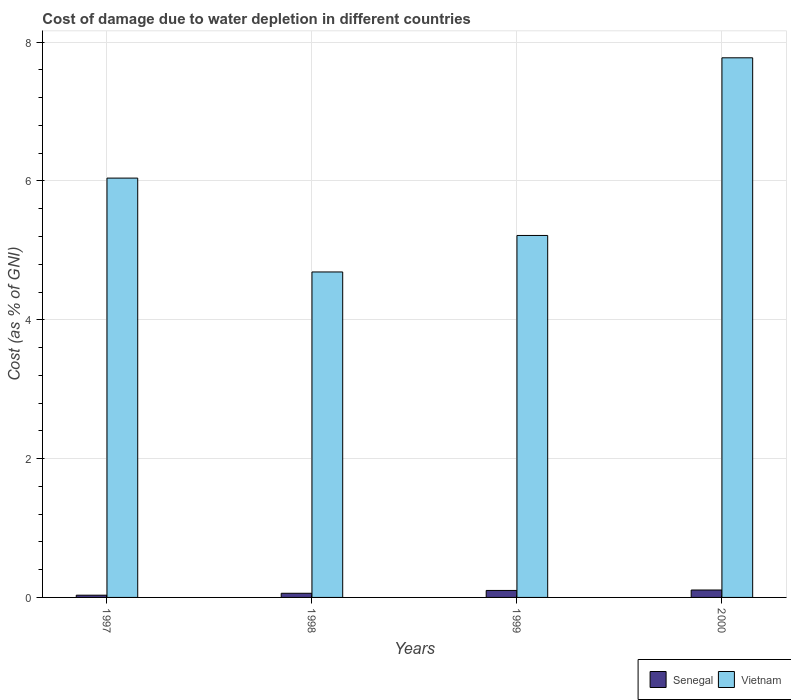How many groups of bars are there?
Provide a short and direct response. 4. Are the number of bars per tick equal to the number of legend labels?
Offer a terse response. Yes. Are the number of bars on each tick of the X-axis equal?
Make the answer very short. Yes. How many bars are there on the 1st tick from the left?
Give a very brief answer. 2. What is the cost of damage caused due to water depletion in Vietnam in 1999?
Your response must be concise. 5.21. Across all years, what is the maximum cost of damage caused due to water depletion in Senegal?
Give a very brief answer. 0.11. Across all years, what is the minimum cost of damage caused due to water depletion in Vietnam?
Give a very brief answer. 4.69. What is the total cost of damage caused due to water depletion in Senegal in the graph?
Make the answer very short. 0.3. What is the difference between the cost of damage caused due to water depletion in Senegal in 1997 and that in 2000?
Offer a terse response. -0.07. What is the difference between the cost of damage caused due to water depletion in Senegal in 1998 and the cost of damage caused due to water depletion in Vietnam in 1999?
Give a very brief answer. -5.15. What is the average cost of damage caused due to water depletion in Senegal per year?
Keep it short and to the point. 0.07. In the year 2000, what is the difference between the cost of damage caused due to water depletion in Senegal and cost of damage caused due to water depletion in Vietnam?
Make the answer very short. -7.67. In how many years, is the cost of damage caused due to water depletion in Vietnam greater than 4 %?
Offer a terse response. 4. What is the ratio of the cost of damage caused due to water depletion in Vietnam in 1998 to that in 1999?
Ensure brevity in your answer.  0.9. Is the cost of damage caused due to water depletion in Senegal in 1999 less than that in 2000?
Give a very brief answer. Yes. What is the difference between the highest and the second highest cost of damage caused due to water depletion in Senegal?
Your answer should be very brief. 0.01. What is the difference between the highest and the lowest cost of damage caused due to water depletion in Senegal?
Provide a succinct answer. 0.07. In how many years, is the cost of damage caused due to water depletion in Vietnam greater than the average cost of damage caused due to water depletion in Vietnam taken over all years?
Your answer should be compact. 2. What does the 1st bar from the left in 1999 represents?
Your response must be concise. Senegal. What does the 2nd bar from the right in 1997 represents?
Your response must be concise. Senegal. Are the values on the major ticks of Y-axis written in scientific E-notation?
Provide a short and direct response. No. Does the graph contain any zero values?
Ensure brevity in your answer.  No. Does the graph contain grids?
Provide a succinct answer. Yes. Where does the legend appear in the graph?
Give a very brief answer. Bottom right. How many legend labels are there?
Make the answer very short. 2. How are the legend labels stacked?
Keep it short and to the point. Horizontal. What is the title of the graph?
Give a very brief answer. Cost of damage due to water depletion in different countries. What is the label or title of the X-axis?
Make the answer very short. Years. What is the label or title of the Y-axis?
Keep it short and to the point. Cost (as % of GNI). What is the Cost (as % of GNI) of Senegal in 1997?
Keep it short and to the point. 0.03. What is the Cost (as % of GNI) in Vietnam in 1997?
Give a very brief answer. 6.04. What is the Cost (as % of GNI) in Senegal in 1998?
Your response must be concise. 0.06. What is the Cost (as % of GNI) in Vietnam in 1998?
Provide a short and direct response. 4.69. What is the Cost (as % of GNI) in Senegal in 1999?
Provide a short and direct response. 0.1. What is the Cost (as % of GNI) in Vietnam in 1999?
Your answer should be compact. 5.21. What is the Cost (as % of GNI) in Senegal in 2000?
Offer a very short reply. 0.11. What is the Cost (as % of GNI) in Vietnam in 2000?
Provide a short and direct response. 7.77. Across all years, what is the maximum Cost (as % of GNI) in Senegal?
Offer a very short reply. 0.11. Across all years, what is the maximum Cost (as % of GNI) of Vietnam?
Provide a short and direct response. 7.77. Across all years, what is the minimum Cost (as % of GNI) in Senegal?
Make the answer very short. 0.03. Across all years, what is the minimum Cost (as % of GNI) in Vietnam?
Provide a succinct answer. 4.69. What is the total Cost (as % of GNI) of Senegal in the graph?
Your answer should be compact. 0.3. What is the total Cost (as % of GNI) in Vietnam in the graph?
Make the answer very short. 23.72. What is the difference between the Cost (as % of GNI) of Senegal in 1997 and that in 1998?
Offer a terse response. -0.03. What is the difference between the Cost (as % of GNI) in Vietnam in 1997 and that in 1998?
Provide a succinct answer. 1.35. What is the difference between the Cost (as % of GNI) of Senegal in 1997 and that in 1999?
Offer a very short reply. -0.07. What is the difference between the Cost (as % of GNI) of Vietnam in 1997 and that in 1999?
Your answer should be very brief. 0.83. What is the difference between the Cost (as % of GNI) of Senegal in 1997 and that in 2000?
Provide a succinct answer. -0.07. What is the difference between the Cost (as % of GNI) of Vietnam in 1997 and that in 2000?
Your response must be concise. -1.73. What is the difference between the Cost (as % of GNI) of Senegal in 1998 and that in 1999?
Your answer should be very brief. -0.04. What is the difference between the Cost (as % of GNI) of Vietnam in 1998 and that in 1999?
Your response must be concise. -0.53. What is the difference between the Cost (as % of GNI) of Senegal in 1998 and that in 2000?
Offer a very short reply. -0.05. What is the difference between the Cost (as % of GNI) in Vietnam in 1998 and that in 2000?
Ensure brevity in your answer.  -3.09. What is the difference between the Cost (as % of GNI) in Senegal in 1999 and that in 2000?
Give a very brief answer. -0.01. What is the difference between the Cost (as % of GNI) of Vietnam in 1999 and that in 2000?
Give a very brief answer. -2.56. What is the difference between the Cost (as % of GNI) of Senegal in 1997 and the Cost (as % of GNI) of Vietnam in 1998?
Your response must be concise. -4.66. What is the difference between the Cost (as % of GNI) in Senegal in 1997 and the Cost (as % of GNI) in Vietnam in 1999?
Ensure brevity in your answer.  -5.18. What is the difference between the Cost (as % of GNI) in Senegal in 1997 and the Cost (as % of GNI) in Vietnam in 2000?
Provide a succinct answer. -7.74. What is the difference between the Cost (as % of GNI) in Senegal in 1998 and the Cost (as % of GNI) in Vietnam in 1999?
Your response must be concise. -5.15. What is the difference between the Cost (as % of GNI) in Senegal in 1998 and the Cost (as % of GNI) in Vietnam in 2000?
Your answer should be compact. -7.71. What is the difference between the Cost (as % of GNI) of Senegal in 1999 and the Cost (as % of GNI) of Vietnam in 2000?
Offer a very short reply. -7.67. What is the average Cost (as % of GNI) of Senegal per year?
Your answer should be compact. 0.07. What is the average Cost (as % of GNI) in Vietnam per year?
Provide a short and direct response. 5.93. In the year 1997, what is the difference between the Cost (as % of GNI) of Senegal and Cost (as % of GNI) of Vietnam?
Offer a very short reply. -6.01. In the year 1998, what is the difference between the Cost (as % of GNI) in Senegal and Cost (as % of GNI) in Vietnam?
Make the answer very short. -4.63. In the year 1999, what is the difference between the Cost (as % of GNI) of Senegal and Cost (as % of GNI) of Vietnam?
Your answer should be very brief. -5.11. In the year 2000, what is the difference between the Cost (as % of GNI) of Senegal and Cost (as % of GNI) of Vietnam?
Ensure brevity in your answer.  -7.67. What is the ratio of the Cost (as % of GNI) of Senegal in 1997 to that in 1998?
Keep it short and to the point. 0.54. What is the ratio of the Cost (as % of GNI) in Vietnam in 1997 to that in 1998?
Give a very brief answer. 1.29. What is the ratio of the Cost (as % of GNI) in Senegal in 1997 to that in 1999?
Provide a short and direct response. 0.32. What is the ratio of the Cost (as % of GNI) in Vietnam in 1997 to that in 1999?
Provide a short and direct response. 1.16. What is the ratio of the Cost (as % of GNI) in Senegal in 1997 to that in 2000?
Provide a short and direct response. 0.3. What is the ratio of the Cost (as % of GNI) of Vietnam in 1997 to that in 2000?
Make the answer very short. 0.78. What is the ratio of the Cost (as % of GNI) of Senegal in 1998 to that in 1999?
Keep it short and to the point. 0.6. What is the ratio of the Cost (as % of GNI) of Vietnam in 1998 to that in 1999?
Ensure brevity in your answer.  0.9. What is the ratio of the Cost (as % of GNI) in Senegal in 1998 to that in 2000?
Ensure brevity in your answer.  0.56. What is the ratio of the Cost (as % of GNI) of Vietnam in 1998 to that in 2000?
Your response must be concise. 0.6. What is the ratio of the Cost (as % of GNI) in Senegal in 1999 to that in 2000?
Keep it short and to the point. 0.94. What is the ratio of the Cost (as % of GNI) in Vietnam in 1999 to that in 2000?
Ensure brevity in your answer.  0.67. What is the difference between the highest and the second highest Cost (as % of GNI) of Senegal?
Keep it short and to the point. 0.01. What is the difference between the highest and the second highest Cost (as % of GNI) in Vietnam?
Your answer should be very brief. 1.73. What is the difference between the highest and the lowest Cost (as % of GNI) in Senegal?
Provide a succinct answer. 0.07. What is the difference between the highest and the lowest Cost (as % of GNI) in Vietnam?
Offer a very short reply. 3.09. 